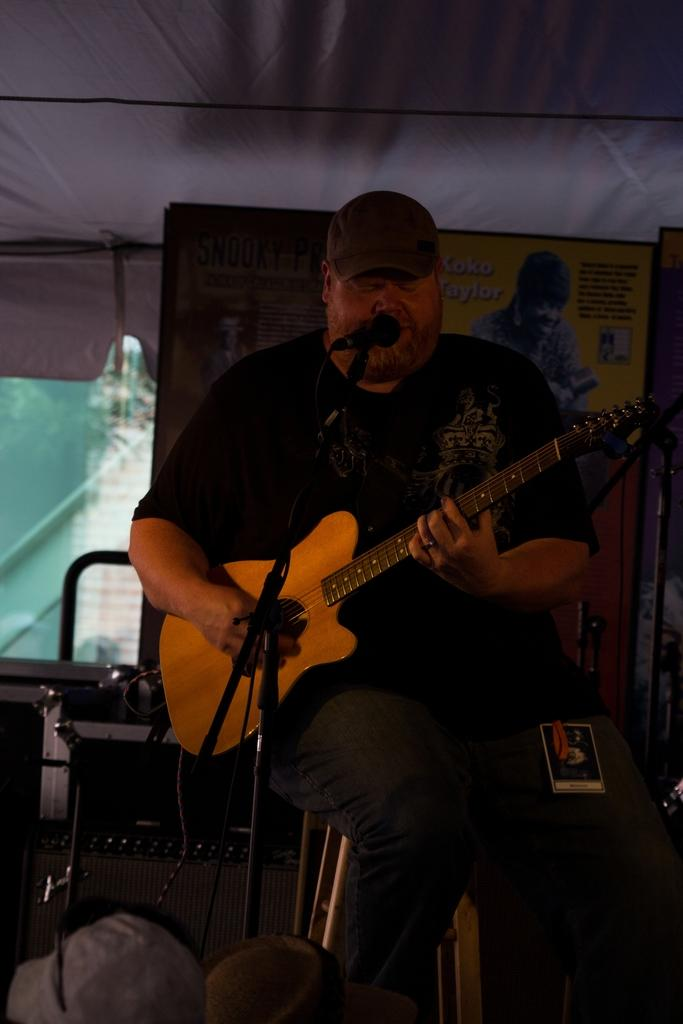What is the man in the image doing? The man is playing a guitar and holding a microphone. What object is the man using to amplify his voice? The man is holding a microphone. What can be seen in the background of the image? There is a window in the background of the image. What is the man standing near in the image? There is a stand in the image. Can you tell me how many maids are present in the image? There are no maids present in the image; it features a man playing a guitar and holding a microphone. What type of joke is the man telling in the image? There is no joke being told in the image; the man is playing a guitar and holding a microphone. 